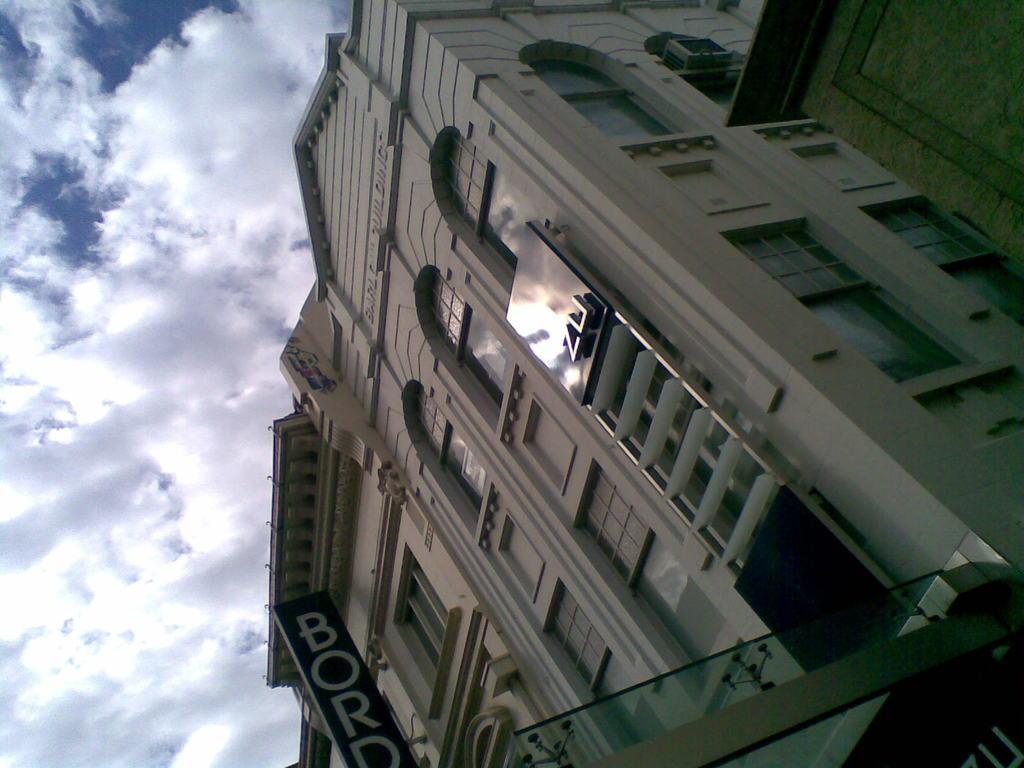Please provide a concise description of this image. In the center of the image there are buildings. At the bottom we can see a board. In the background there is sky. 